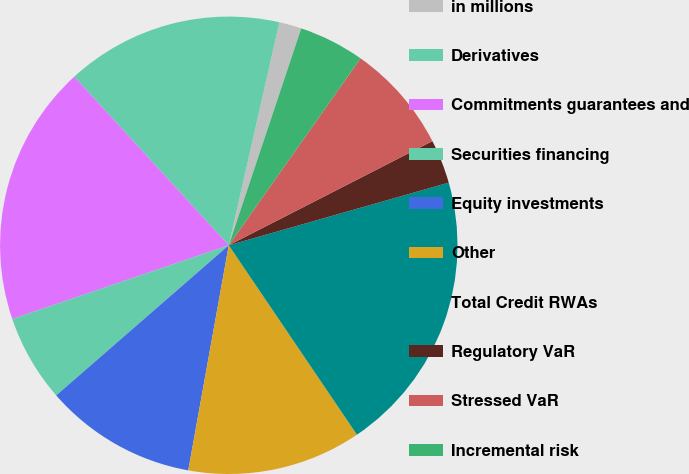Convert chart. <chart><loc_0><loc_0><loc_500><loc_500><pie_chart><fcel>in millions<fcel>Derivatives<fcel>Commitments guarantees and<fcel>Securities financing<fcel>Equity investments<fcel>Other<fcel>Total Credit RWAs<fcel>Regulatory VaR<fcel>Stressed VaR<fcel>Incremental risk<nl><fcel>1.58%<fcel>15.36%<fcel>18.42%<fcel>6.17%<fcel>10.77%<fcel>12.3%<fcel>19.95%<fcel>3.11%<fcel>7.7%<fcel>4.64%<nl></chart> 